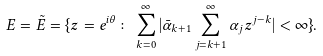<formula> <loc_0><loc_0><loc_500><loc_500>E = \tilde { E } = \{ z = e ^ { i \theta } \colon \sum _ { k = 0 } ^ { \infty } | \bar { \alpha } _ { k + 1 } \sum _ { j = k + 1 } ^ { \infty } \alpha _ { j } z ^ { j - k } | < \infty \} .</formula> 